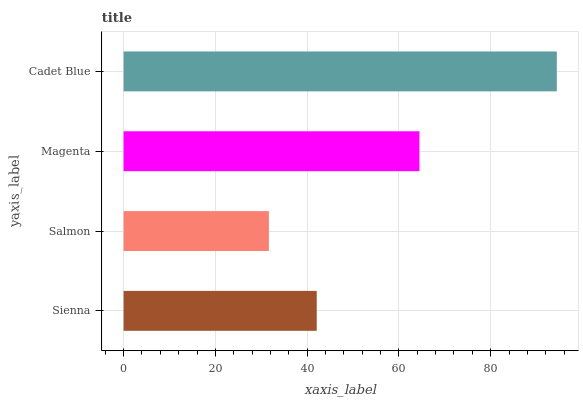Is Salmon the minimum?
Answer yes or no. Yes. Is Cadet Blue the maximum?
Answer yes or no. Yes. Is Magenta the minimum?
Answer yes or no. No. Is Magenta the maximum?
Answer yes or no. No. Is Magenta greater than Salmon?
Answer yes or no. Yes. Is Salmon less than Magenta?
Answer yes or no. Yes. Is Salmon greater than Magenta?
Answer yes or no. No. Is Magenta less than Salmon?
Answer yes or no. No. Is Magenta the high median?
Answer yes or no. Yes. Is Sienna the low median?
Answer yes or no. Yes. Is Sienna the high median?
Answer yes or no. No. Is Salmon the low median?
Answer yes or no. No. 